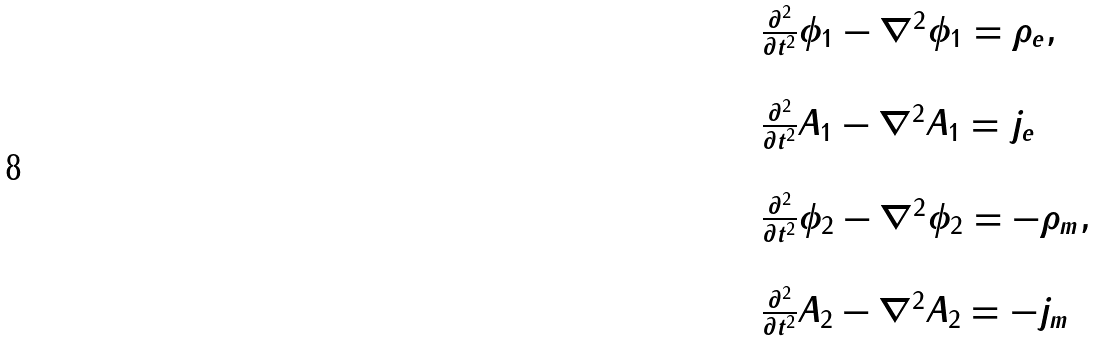Convert formula to latex. <formula><loc_0><loc_0><loc_500><loc_500>\begin{array} { l } \frac { \partial ^ { 2 } } { \partial t ^ { 2 } } \phi _ { 1 } - \nabla ^ { 2 } \phi _ { 1 } = \rho _ { e } , \\ \\ \frac { \partial ^ { 2 } } { \partial t ^ { 2 } } A _ { 1 } - \nabla ^ { 2 } A _ { 1 } = j _ { e } \\ \\ \frac { \partial ^ { 2 } } { \partial t ^ { 2 } } \phi _ { 2 } - \nabla ^ { 2 } \phi _ { 2 } = - \rho _ { m } , \\ \\ \frac { \partial ^ { 2 } } { \partial t ^ { 2 } } A _ { 2 } - \nabla ^ { 2 } A _ { 2 } = - j _ { m } \\ \end{array}</formula> 